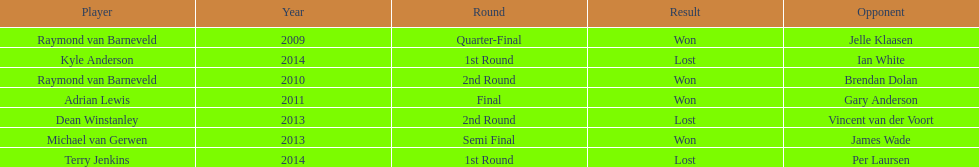Who won the first world darts championship? Raymond van Barneveld. 